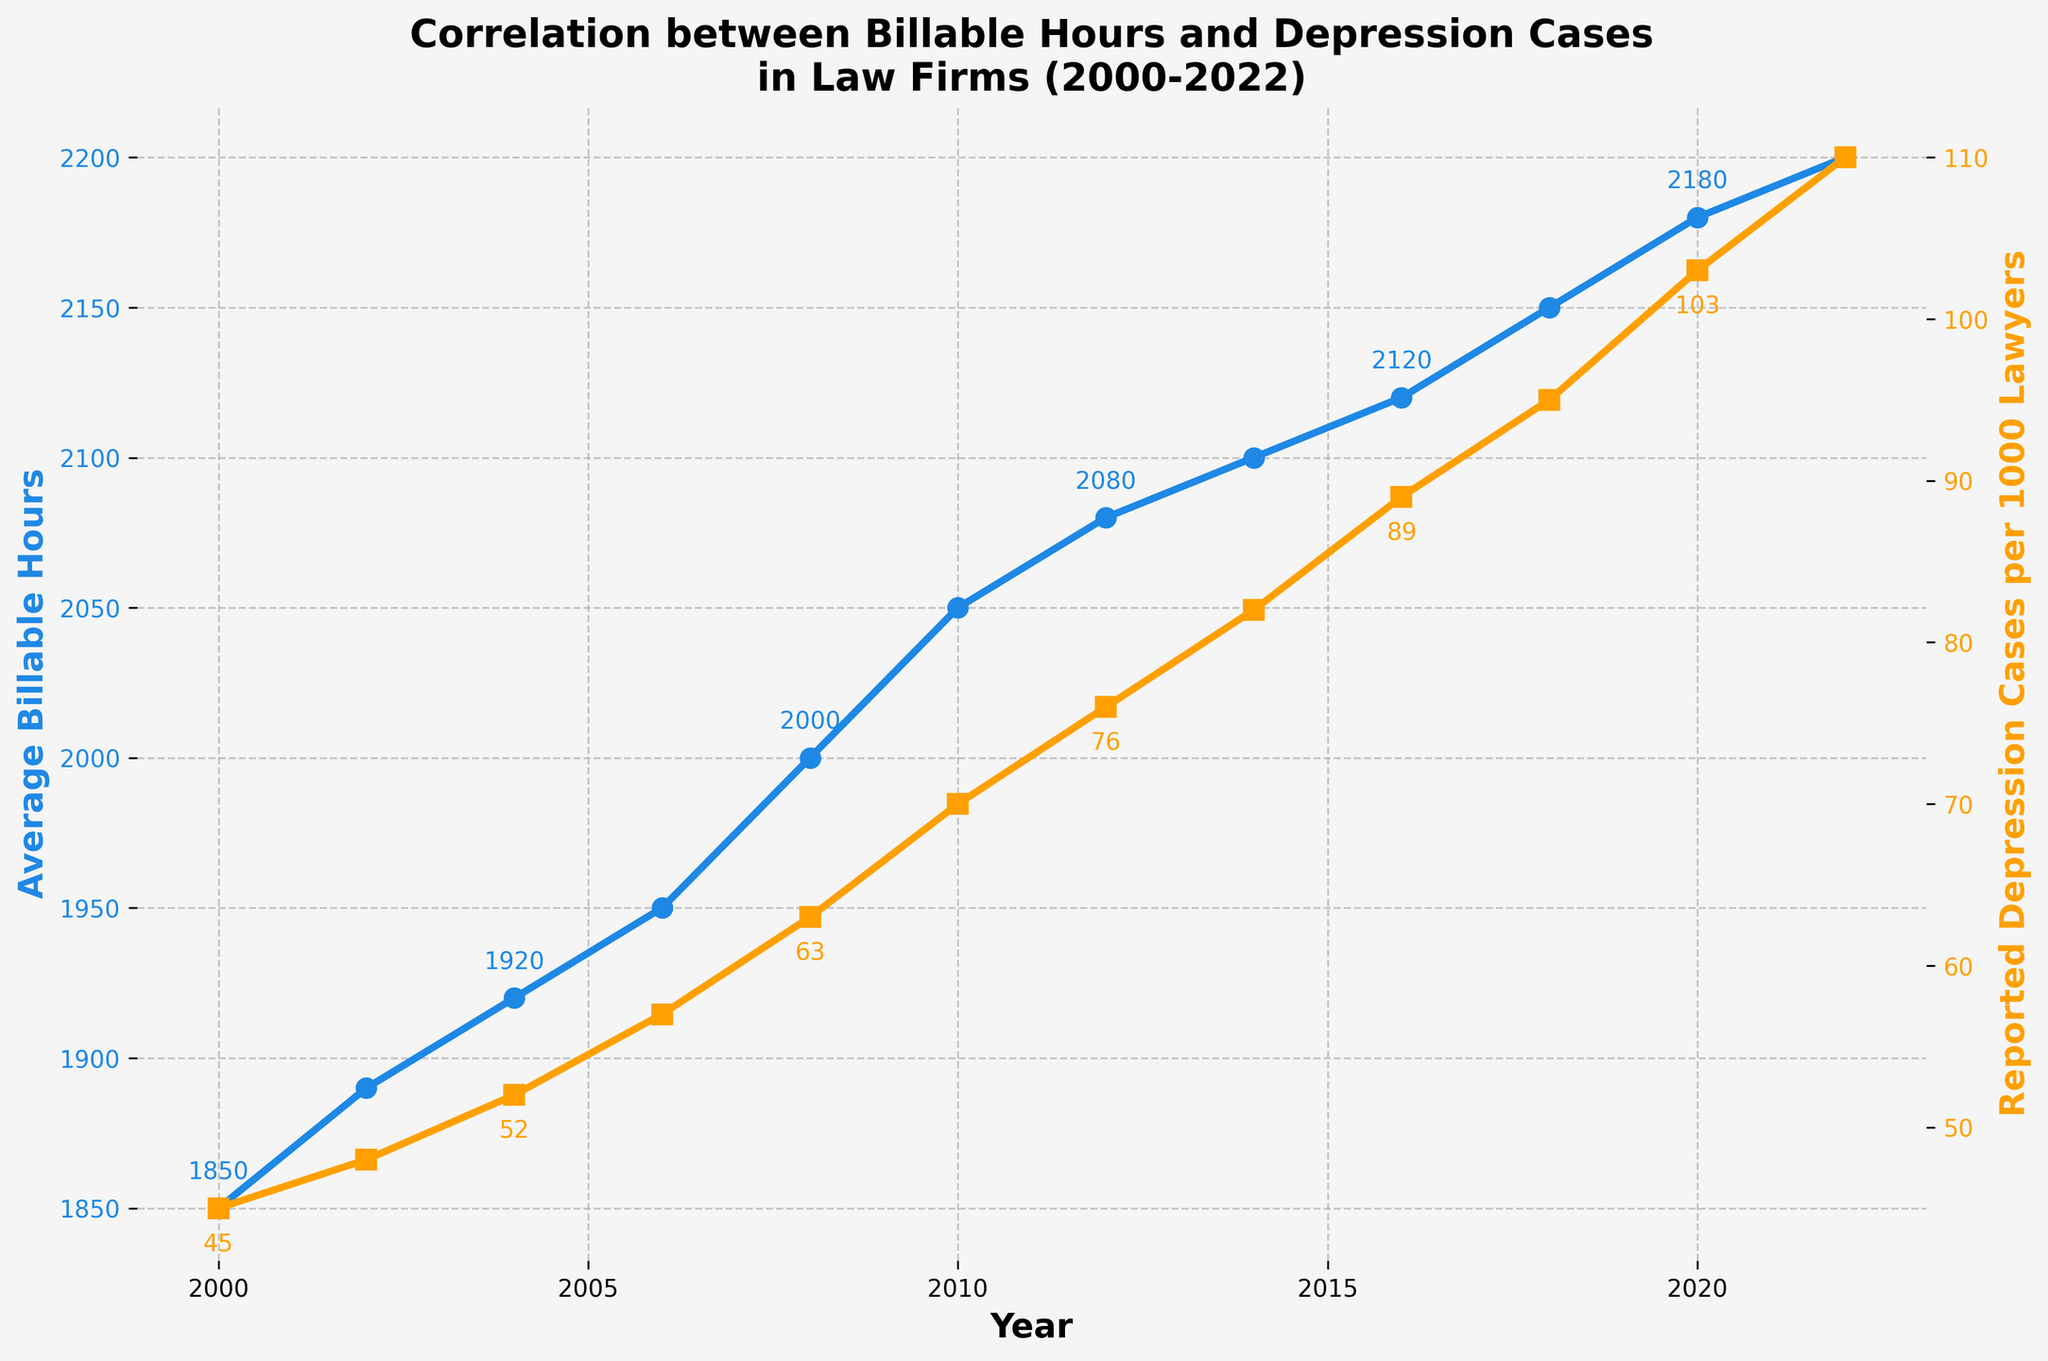What is the trend in average billable hours from 2000 to 2022? To determine the trend, examine the plot line representing average billable hours over the years. The line shows an upward trend from 1850 hours in 2000 to 2200 hours in 2022, indicating that average billable hours have been increasing.
Answer: Increasing Between which years did the reported depression cases per 1000 lawyers increase the most? To find this, look at the biggest vertical difference between consecutive data points on the plot line for reported depression cases per 1000 lawyers. The largest increase seems to be between 2010 and 2012, where cases went from 70 to 76.
Answer: 2010-2012 What was the average increase in reported depression cases per 1000 lawyers each year? Calculate the total increase in reported depression cases from 2000 to 2022 (110 - 45 = 65), then divide by the number of years (2022 - 2000 = 22 years). Thus, the average annual increase is 65/22.
Answer: 2.95 Comparing the years 2006 and 2014, which had a higher number of average billable hours? Refer to the points on the average billable hours line for 2006 (1950) and 2014 (2100). Since 2100 is greater than 1950, 2014 had higher average billable hours.
Answer: 2014 What can you infer about the relationship between average billable hours and reported depression cases per 1000 lawyers over the years? Both the average billable hours and reported depression cases per 1000 lawyers show an increasing trend over the years. This suggests a positive correlation where an increase in billable hours is associated with an increase in reported depression cases.
Answer: Positive correlation In what year did the average billable hours reach 2000? Identify the point on the average billable hours line where it first reaches 2000. This occurs in the year 2008.
Answer: 2008 How much did reported depression cases per 1000 lawyers increase from 2018 to 2022? Locate and subtract the values for 2018 (95) and 2022 (110) on the reported depression cases per 1000 lawyers line. The difference is 110 - 95.
Answer: 15 Is there any year where reported depression cases per 1000 lawyers decreased compared to the previous year? Check the trend line for reported depression cases per 1000 lawyers for any dips. There are no years where the number of reported depression cases per 1000 lawyers decreased compared to the previous year.
Answer: No Which year had the highest reported depression cases per 1000 lawyers? Find the tallest point on the reported depression cases per 1000 lawyers line. This occurs in 2022, with 110 cases.
Answer: 2022 By how much did average billable hours increase between 2000 and 2022? Find and subtract the initial and final values of average billable hours from the plot line: 2200 (2022) - 1850 (2000). This gives the total increase.
Answer: 350 